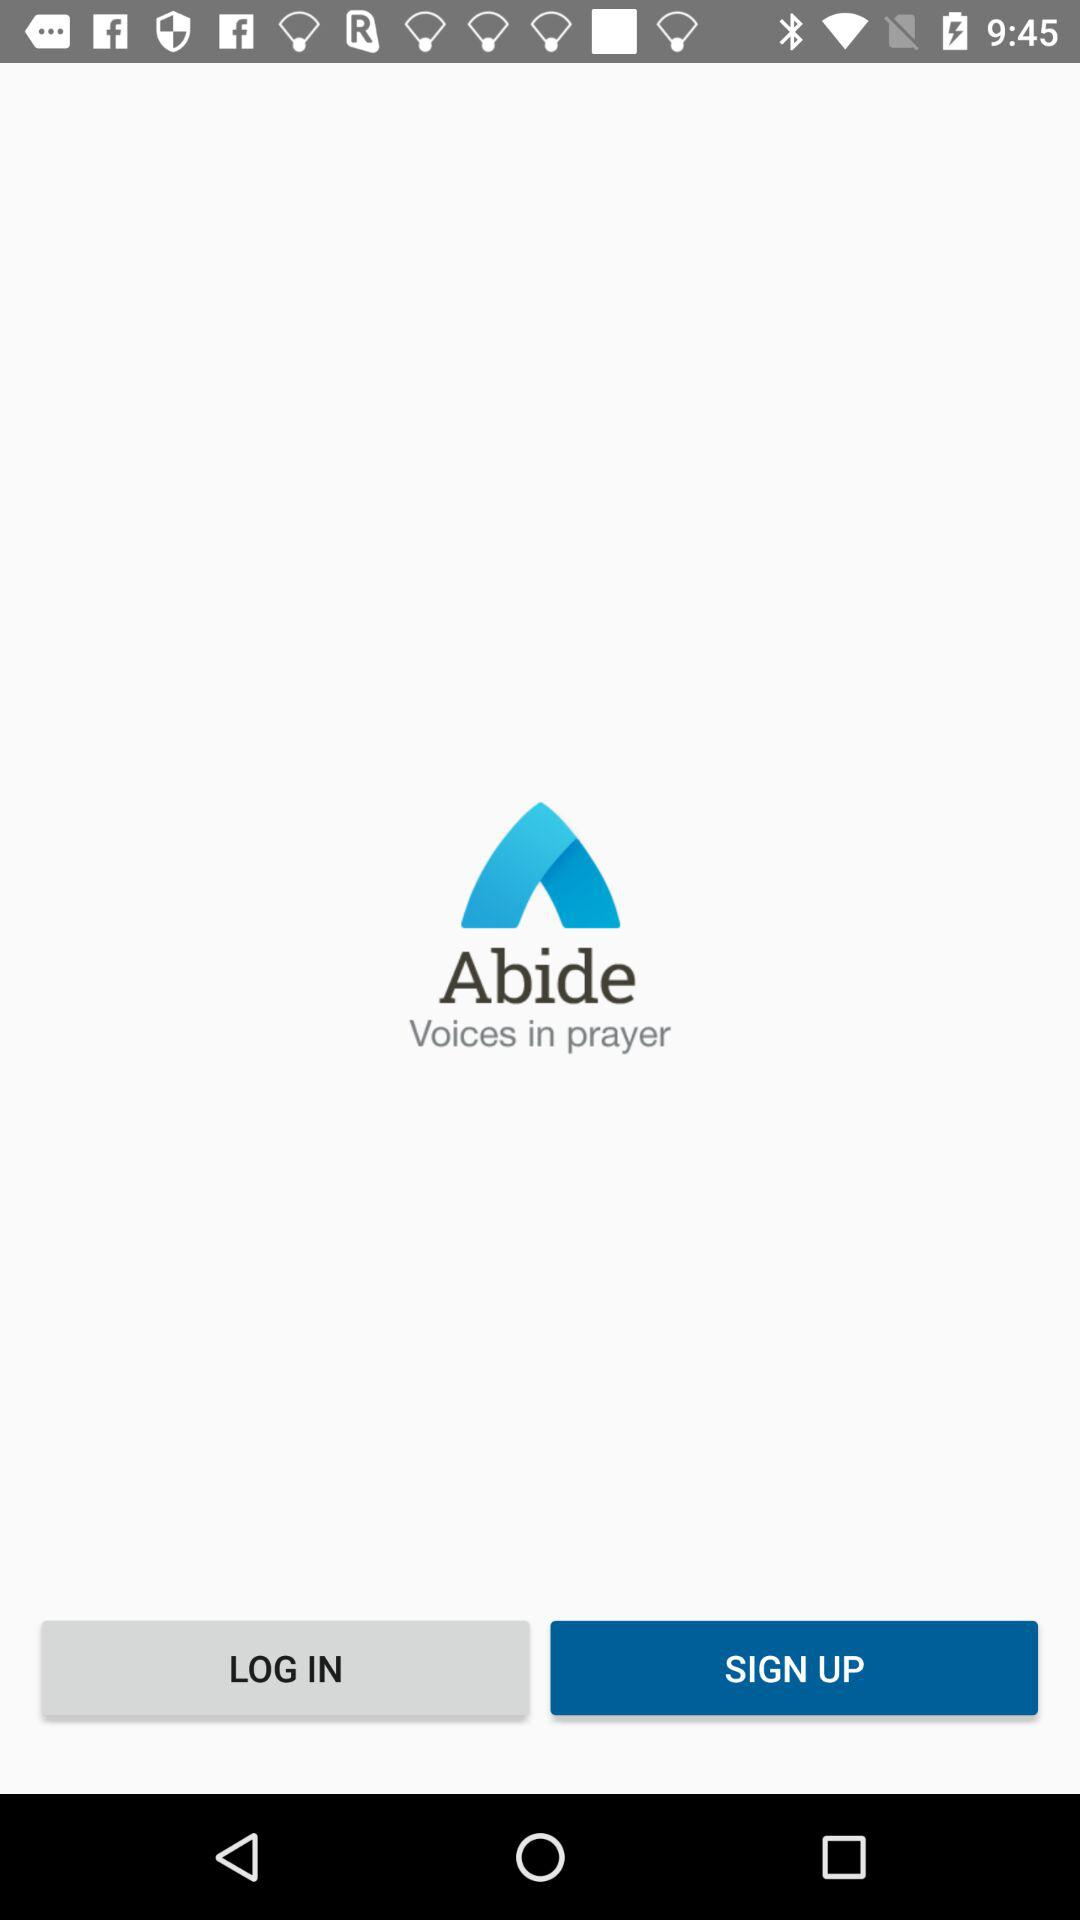What is the application name? The application name is "Abide". 